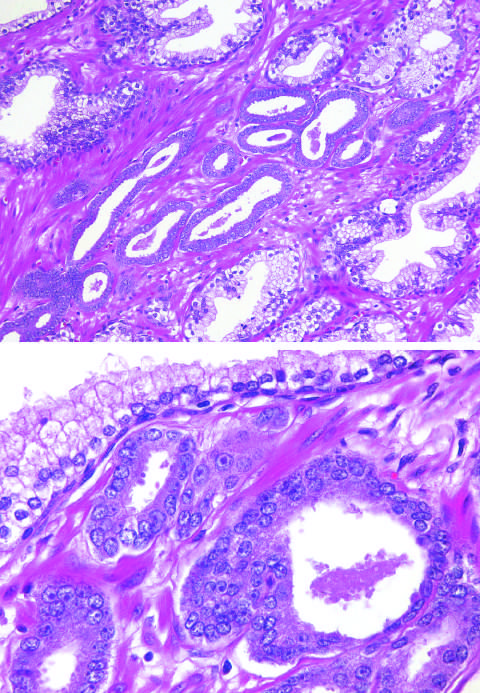does higher magnification show several small malignant glands with enlarged nuclei, prominent nucleoli, and dark cytoplasm, as compared with the larger, benign gland?
Answer the question using a single word or phrase. Yes 